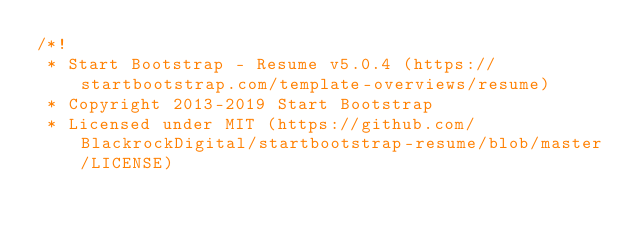Convert code to text. <code><loc_0><loc_0><loc_500><loc_500><_CSS_>/*!
 * Start Bootstrap - Resume v5.0.4 (https://startbootstrap.com/template-overviews/resume)
 * Copyright 2013-2019 Start Bootstrap
 * Licensed under MIT (https://github.com/BlackrockDigital/startbootstrap-resume/blob/master/LICENSE)</code> 